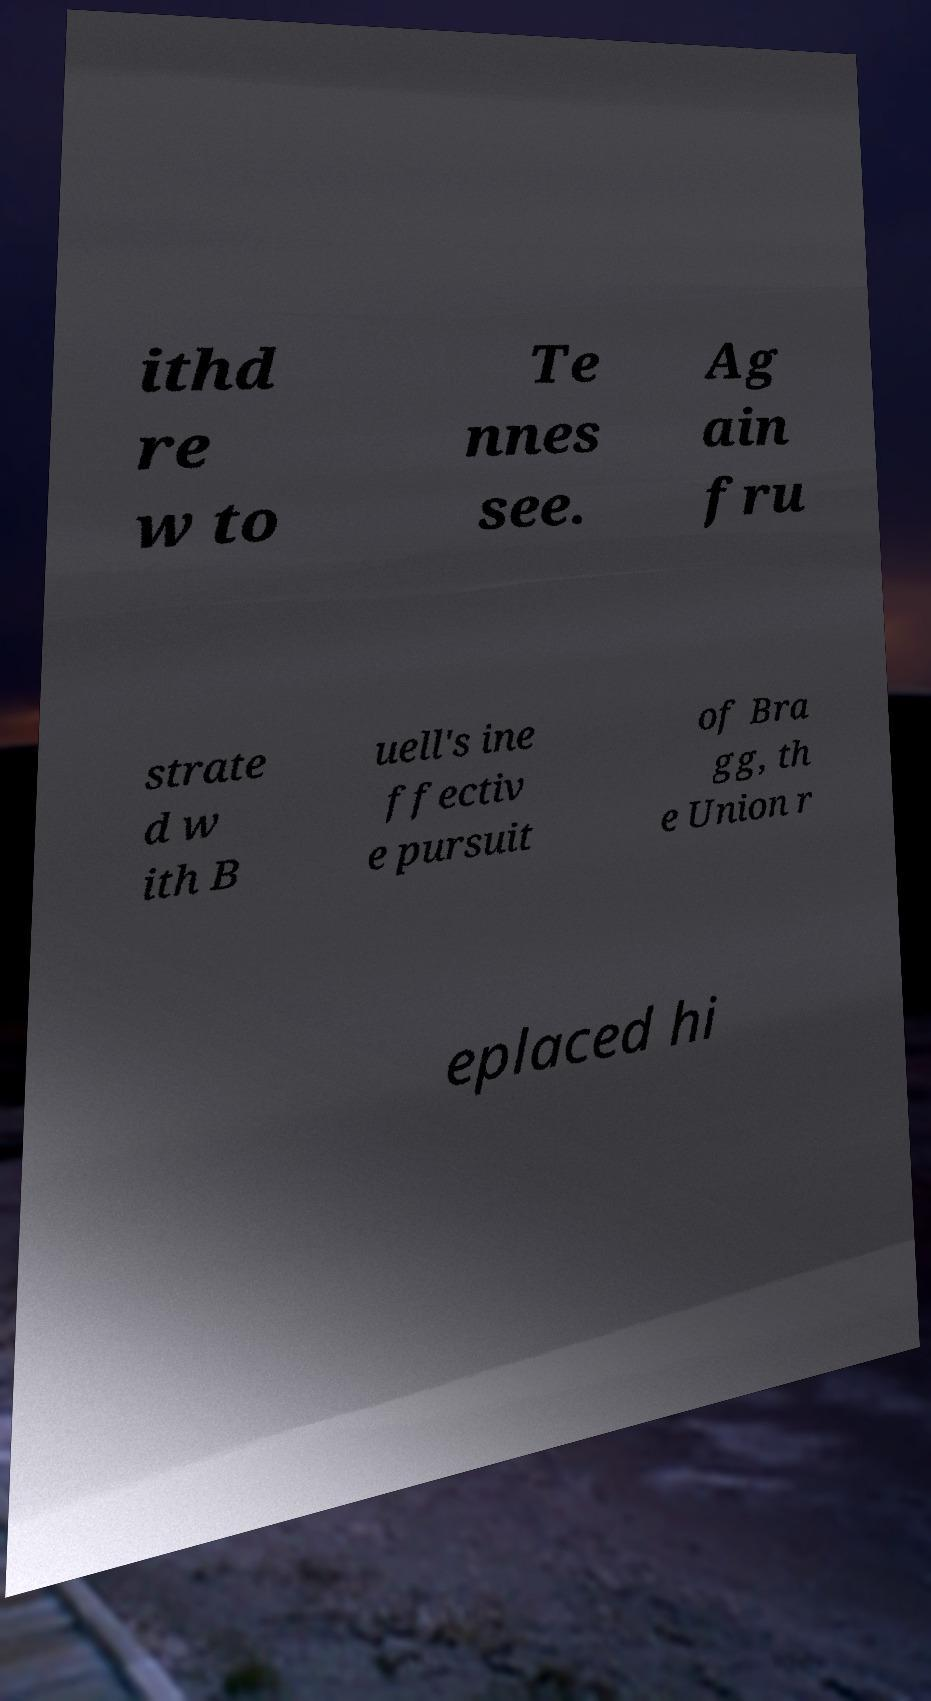Can you read and provide the text displayed in the image?This photo seems to have some interesting text. Can you extract and type it out for me? ithd re w to Te nnes see. Ag ain fru strate d w ith B uell's ine ffectiv e pursuit of Bra gg, th e Union r eplaced hi 